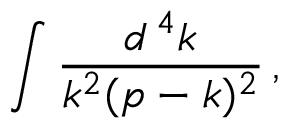Convert formula to latex. <formula><loc_0><loc_0><loc_500><loc_500>\int { \frac { d ^ { \, 4 } k } { k ^ { 2 } ( p - k ) ^ { 2 } } } \, ,</formula> 